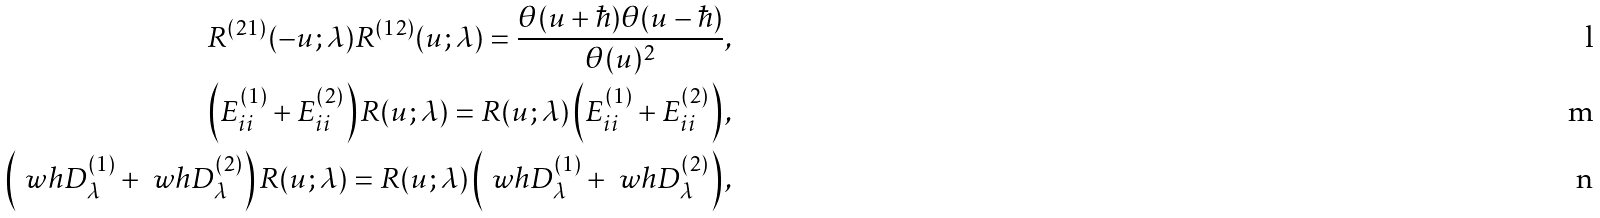<formula> <loc_0><loc_0><loc_500><loc_500>R ^ { ( 2 1 ) } ( - u ; \lambda ) R ^ { ( 1 2 ) } ( u ; \lambda ) = \frac { \theta ( u + \hbar { ) } \theta ( u - \hbar { ) } } { \theta ( u ) ^ { 2 } } , \\ \left ( E ^ { ( 1 ) } _ { i i } + E ^ { ( 2 ) } _ { i i } \right ) R ( u ; \lambda ) = R ( u ; \lambda ) \left ( E ^ { ( 1 ) } _ { i i } + E ^ { ( 2 ) } _ { i i } \right ) , \\ \left ( \ w h D ^ { ( 1 ) } _ { \lambda } + \ w h D ^ { ( 2 ) } _ { \lambda } \right ) R ( u ; \lambda ) = R ( u ; \lambda ) \left ( \ w h D ^ { ( 1 ) } _ { \lambda } + \ w h D ^ { ( 2 ) } _ { \lambda } \right ) ,</formula> 